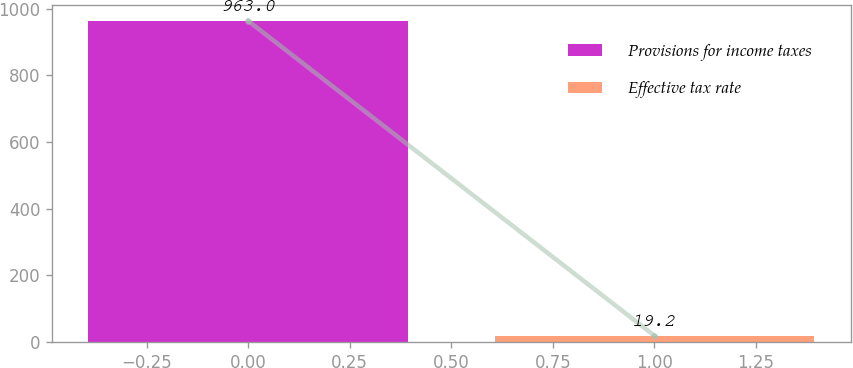Convert chart to OTSL. <chart><loc_0><loc_0><loc_500><loc_500><bar_chart><fcel>Provisions for income taxes<fcel>Effective tax rate<nl><fcel>963<fcel>19.2<nl></chart> 